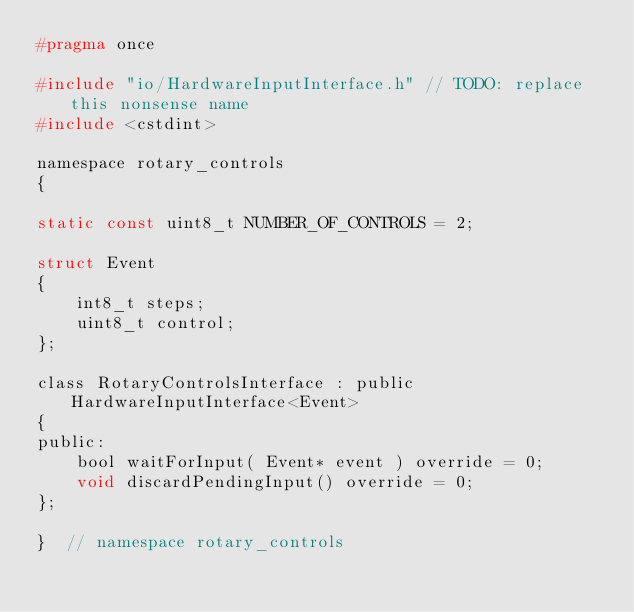Convert code to text. <code><loc_0><loc_0><loc_500><loc_500><_C_>#pragma once

#include "io/HardwareInputInterface.h" // TODO: replace this nonsense name
#include <cstdint>

namespace rotary_controls
{

static const uint8_t NUMBER_OF_CONTROLS = 2;

struct Event
{
    int8_t steps;
    uint8_t control;
};

class RotaryControlsInterface : public HardwareInputInterface<Event>
{
public:
    bool waitForInput( Event* event ) override = 0;
    void discardPendingInput() override = 0;
};

}  // namespace rotary_controls
</code> 